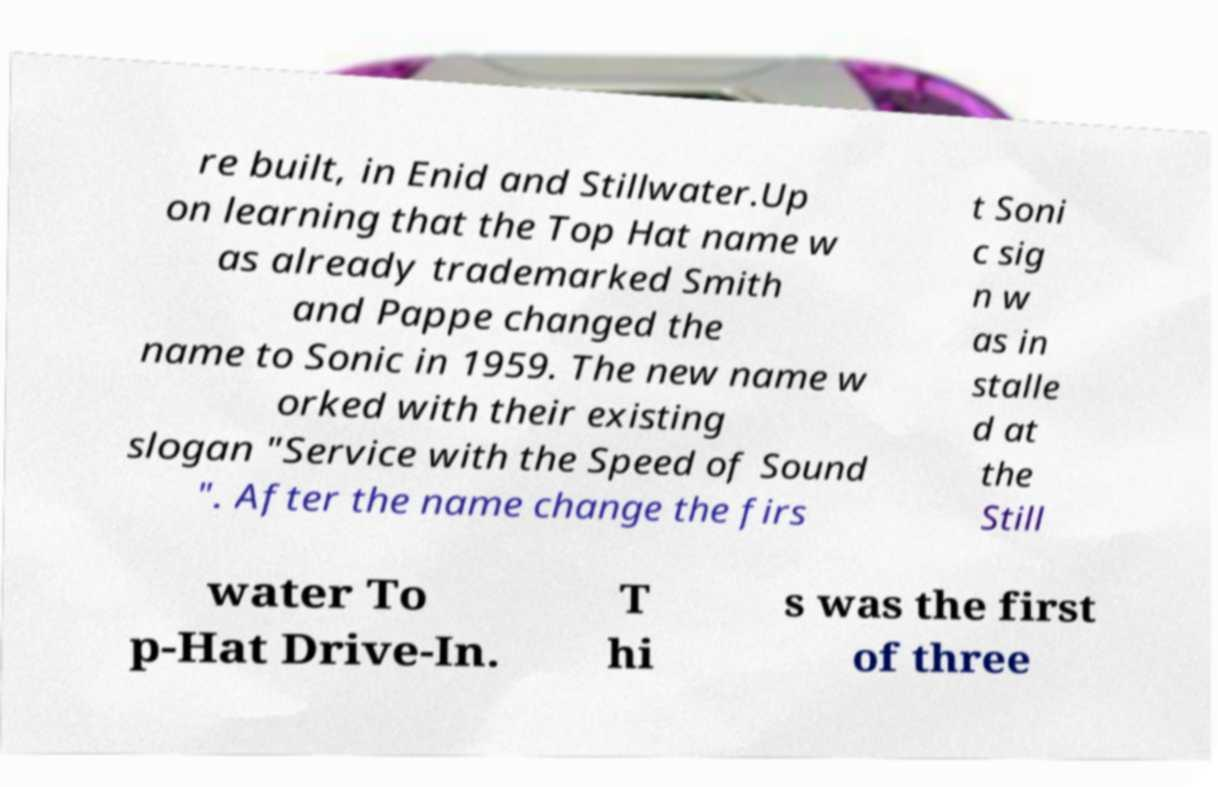Please identify and transcribe the text found in this image. re built, in Enid and Stillwater.Up on learning that the Top Hat name w as already trademarked Smith and Pappe changed the name to Sonic in 1959. The new name w orked with their existing slogan "Service with the Speed of Sound ". After the name change the firs t Soni c sig n w as in stalle d at the Still water To p-Hat Drive-In. T hi s was the first of three 